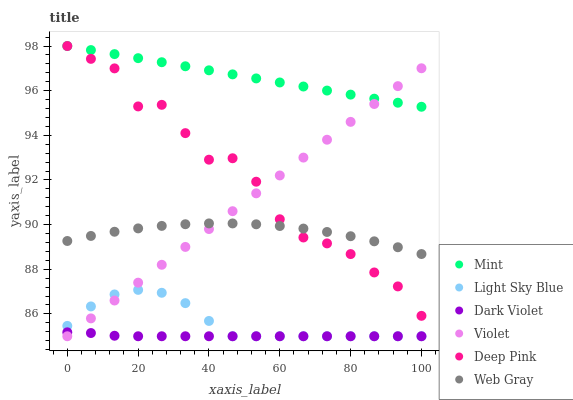Does Dark Violet have the minimum area under the curve?
Answer yes or no. Yes. Does Mint have the maximum area under the curve?
Answer yes or no. Yes. Does Deep Pink have the minimum area under the curve?
Answer yes or no. No. Does Deep Pink have the maximum area under the curve?
Answer yes or no. No. Is Violet the smoothest?
Answer yes or no. Yes. Is Deep Pink the roughest?
Answer yes or no. Yes. Is Light Sky Blue the smoothest?
Answer yes or no. No. Is Light Sky Blue the roughest?
Answer yes or no. No. Does Light Sky Blue have the lowest value?
Answer yes or no. Yes. Does Deep Pink have the lowest value?
Answer yes or no. No. Does Mint have the highest value?
Answer yes or no. Yes. Does Light Sky Blue have the highest value?
Answer yes or no. No. Is Light Sky Blue less than Web Gray?
Answer yes or no. Yes. Is Mint greater than Dark Violet?
Answer yes or no. Yes. Does Violet intersect Deep Pink?
Answer yes or no. Yes. Is Violet less than Deep Pink?
Answer yes or no. No. Is Violet greater than Deep Pink?
Answer yes or no. No. Does Light Sky Blue intersect Web Gray?
Answer yes or no. No. 